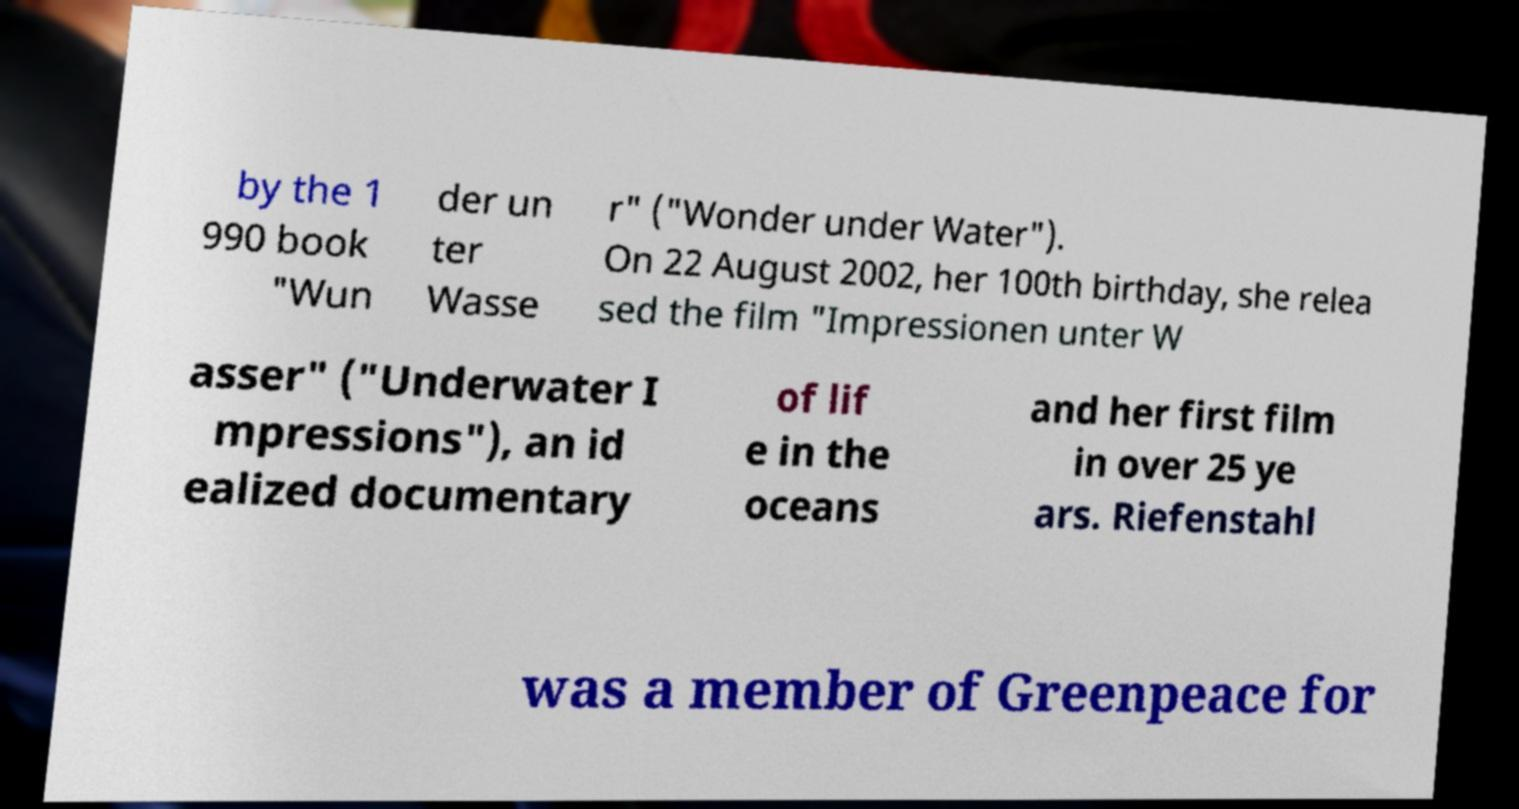For documentation purposes, I need the text within this image transcribed. Could you provide that? by the 1 990 book "Wun der un ter Wasse r" ("Wonder under Water"). On 22 August 2002, her 100th birthday, she relea sed the film "Impressionen unter W asser" ("Underwater I mpressions"), an id ealized documentary of lif e in the oceans and her first film in over 25 ye ars. Riefenstahl was a member of Greenpeace for 